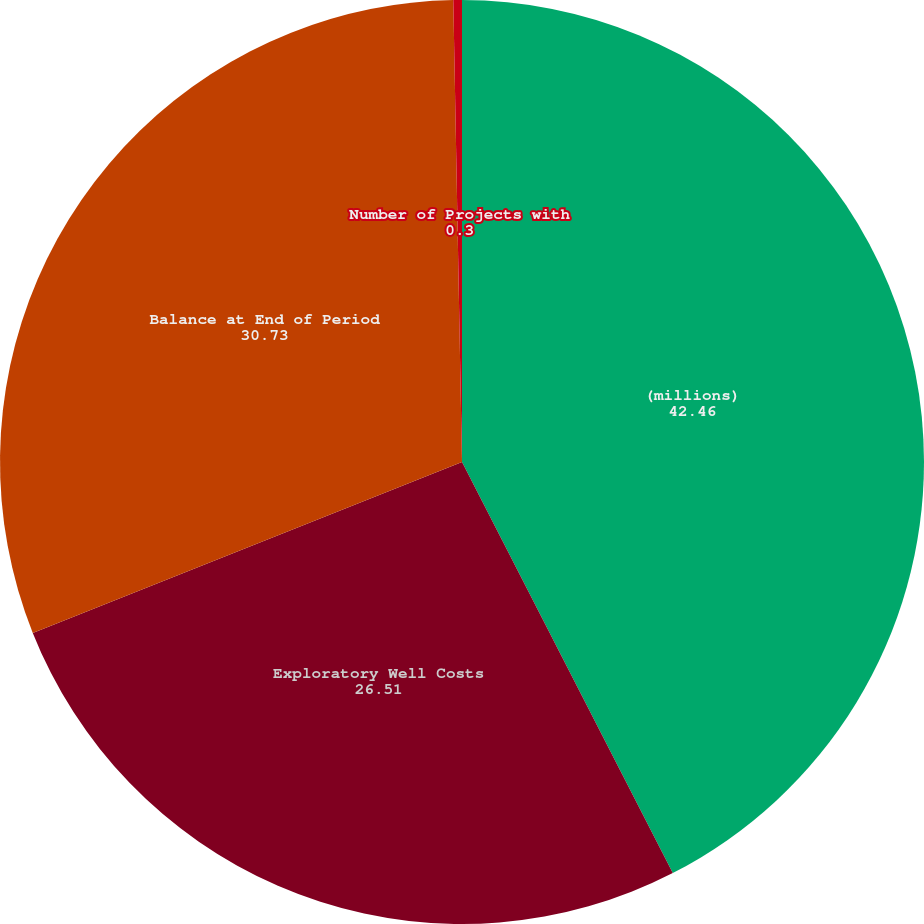<chart> <loc_0><loc_0><loc_500><loc_500><pie_chart><fcel>(millions)<fcel>Exploratory Well Costs<fcel>Balance at End of Period<fcel>Number of Projects with<nl><fcel>42.46%<fcel>26.51%<fcel>30.73%<fcel>0.3%<nl></chart> 